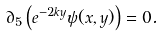Convert formula to latex. <formula><loc_0><loc_0><loc_500><loc_500>\partial _ { 5 } \left ( e ^ { - 2 k y } \psi ( x , y ) \right ) = 0 .</formula> 